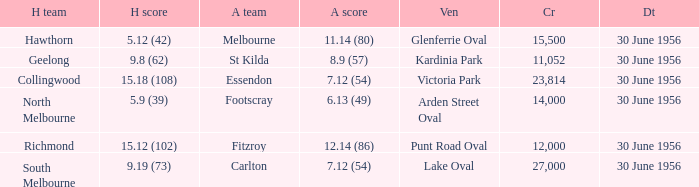What away team has a home team score of 15.18 (108)? Essendon. 